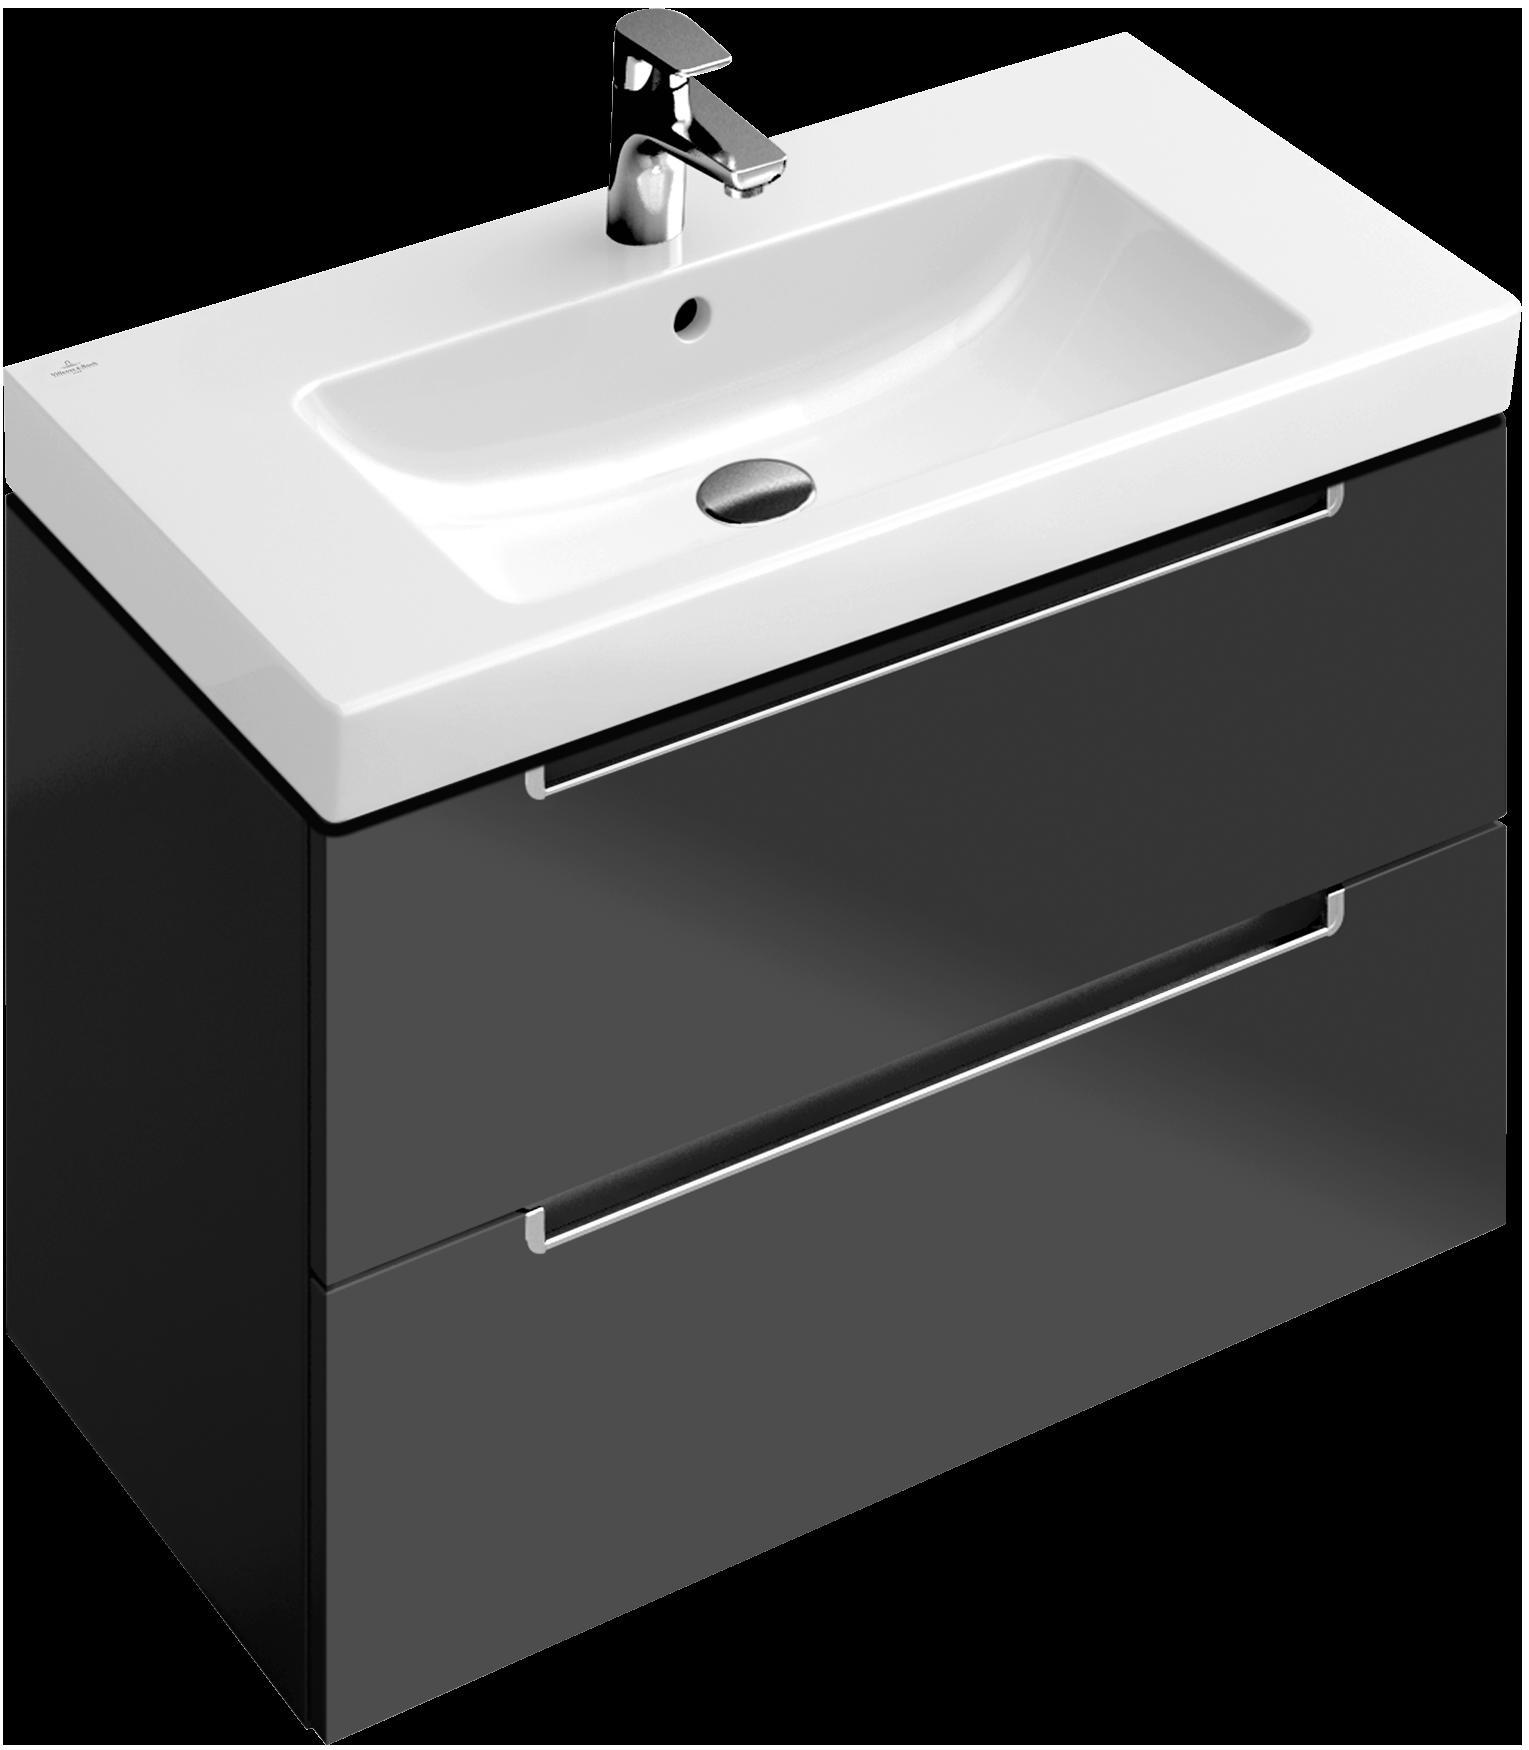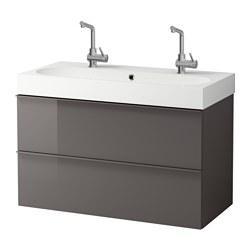The first image is the image on the left, the second image is the image on the right. Given the left and right images, does the statement "Three faucets are visible." hold true? Answer yes or no. Yes. The first image is the image on the left, the second image is the image on the right. For the images shown, is this caption "There are three faucets." true? Answer yes or no. Yes. 